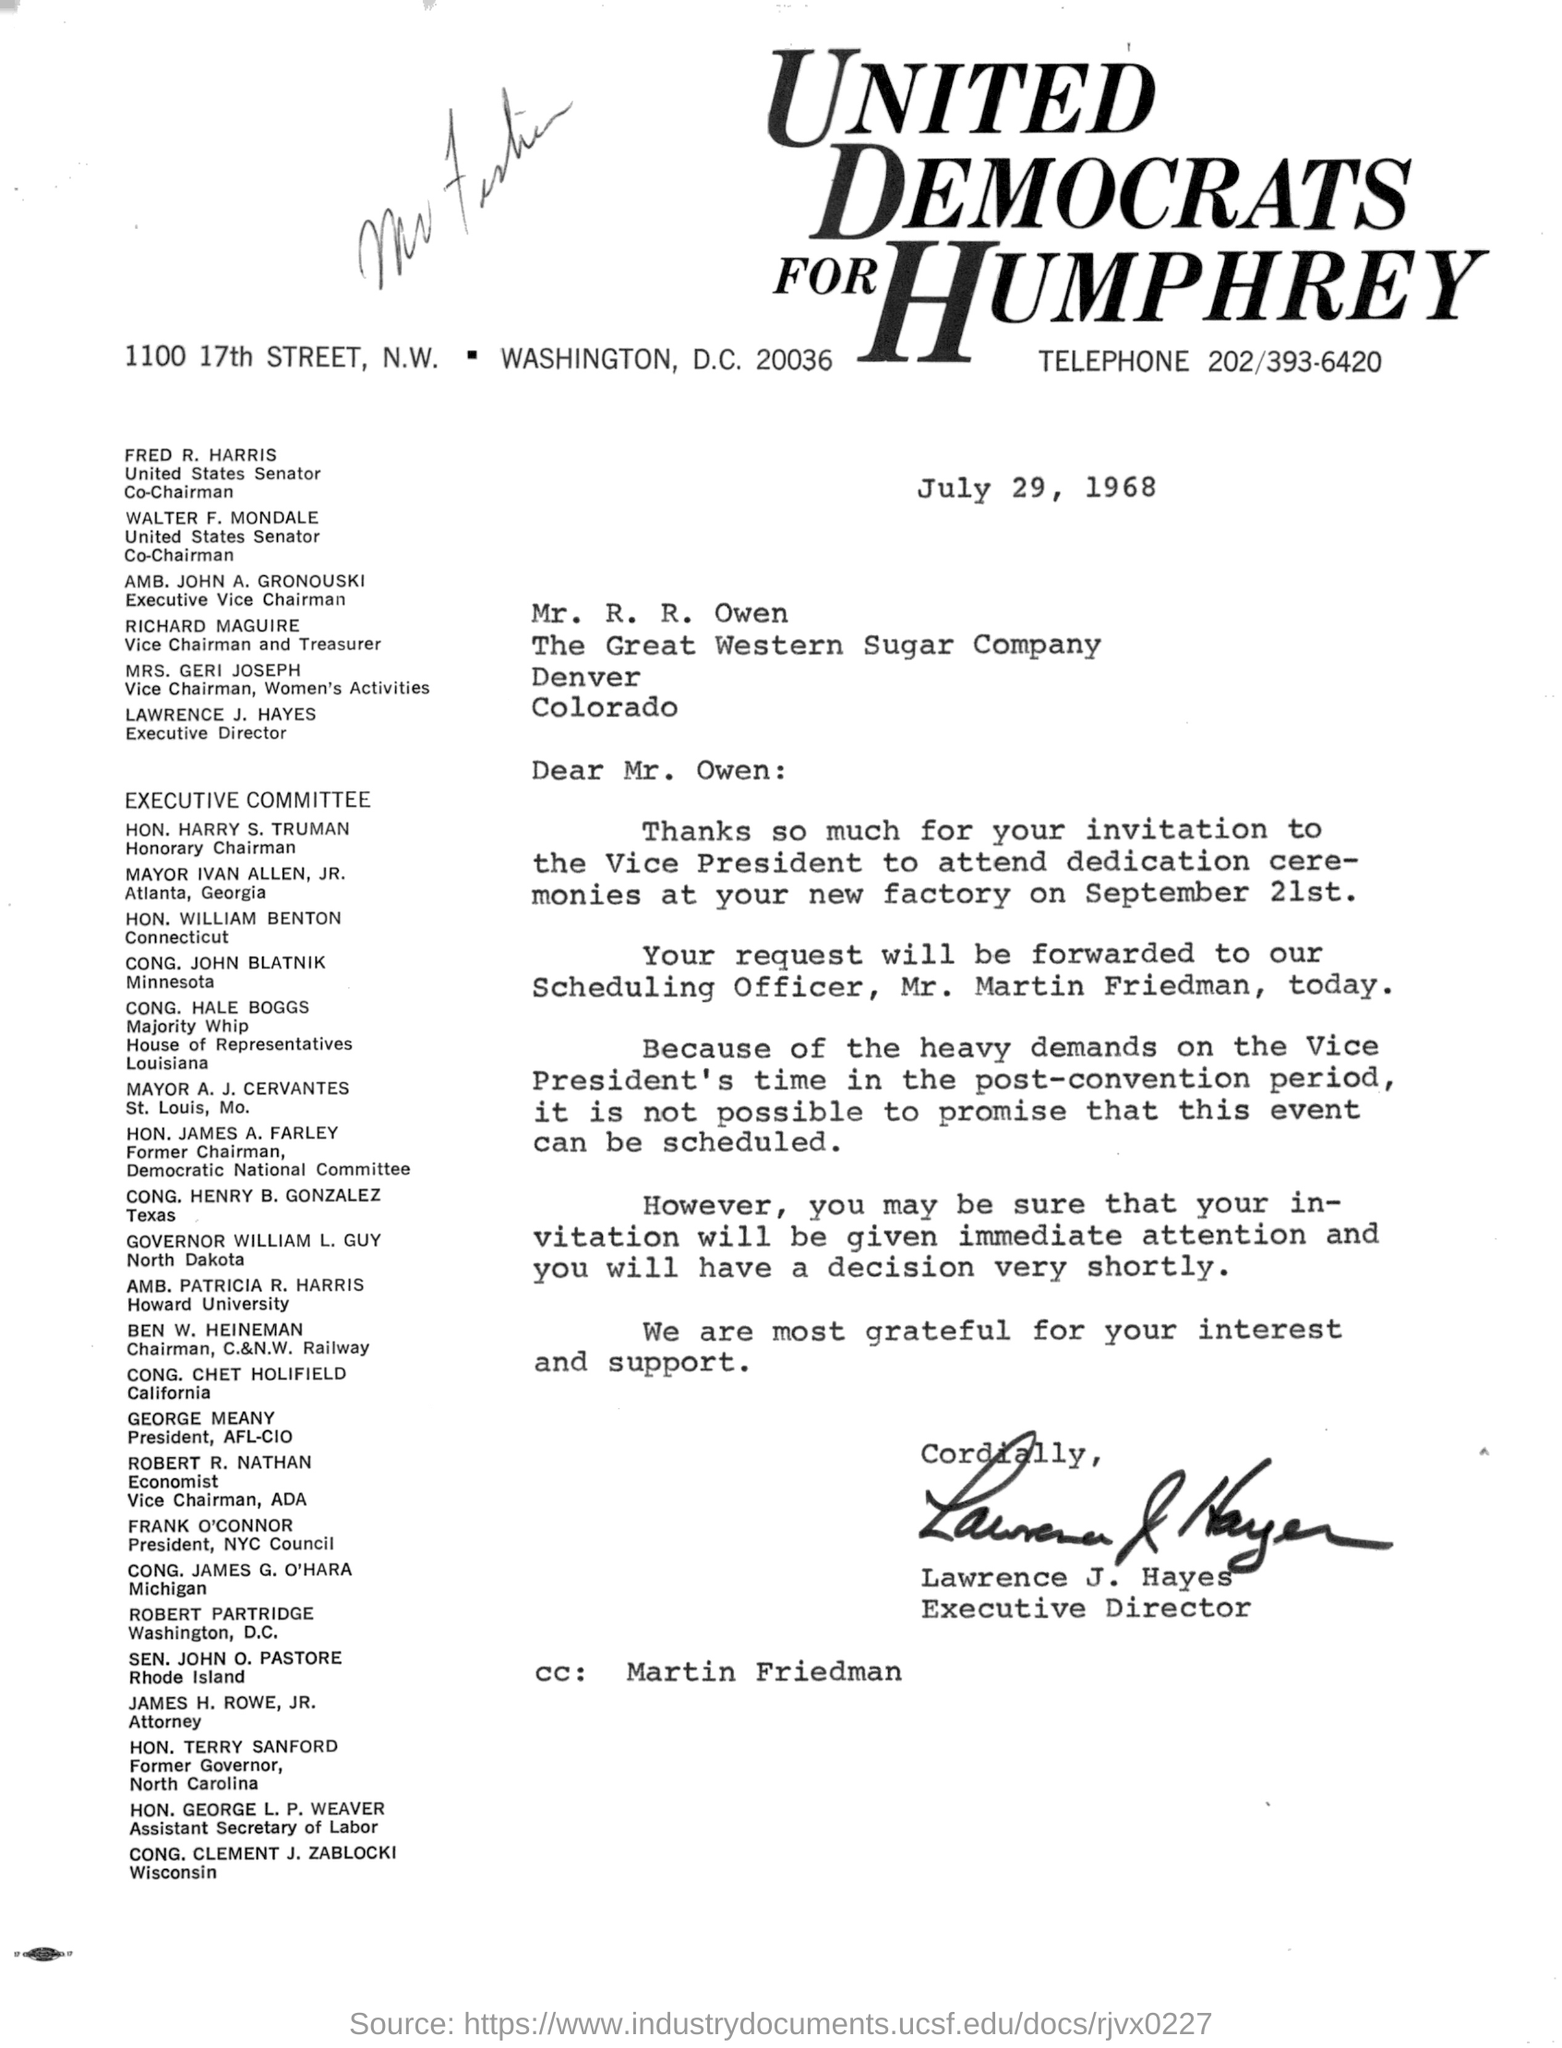What is the date mentioned in the document?
Make the answer very short. July 29, 1968. Who is included in CC ?
Make the answer very short. Martin friedman. 